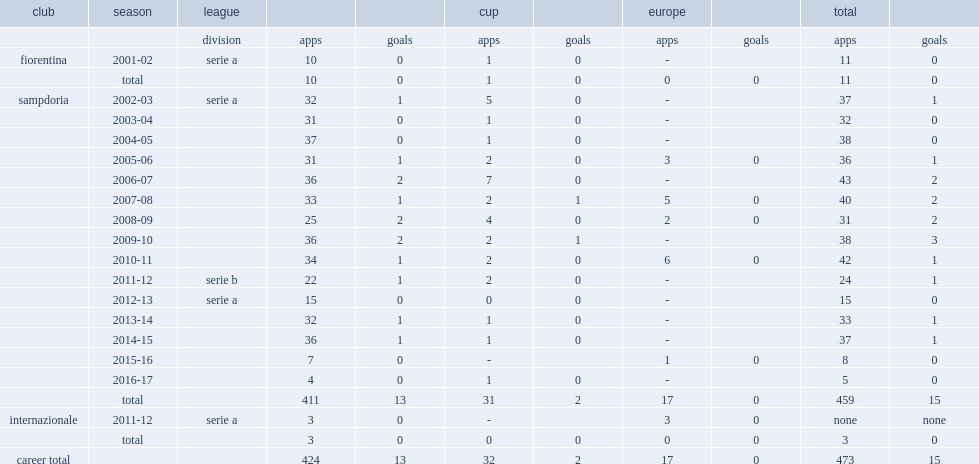How many goals did angelo palombo score for sampdoria in 2005-06? 1.0. 